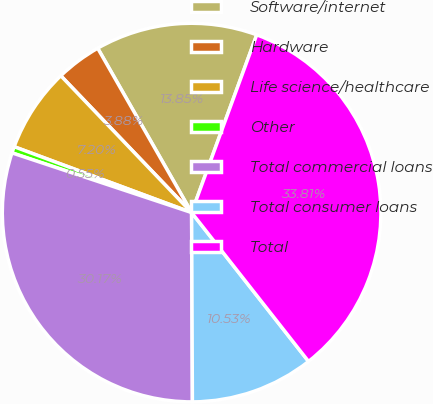Convert chart to OTSL. <chart><loc_0><loc_0><loc_500><loc_500><pie_chart><fcel>Software/internet<fcel>Hardware<fcel>Life science/healthcare<fcel>Other<fcel>Total commercial loans<fcel>Total consumer loans<fcel>Total<nl><fcel>13.85%<fcel>3.88%<fcel>7.2%<fcel>0.55%<fcel>30.17%<fcel>10.53%<fcel>33.81%<nl></chart> 